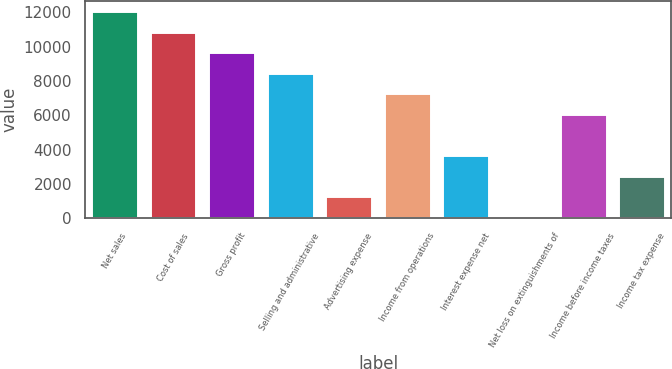<chart> <loc_0><loc_0><loc_500><loc_500><bar_chart><fcel>Net sales<fcel>Cost of sales<fcel>Gross profit<fcel>Selling and administrative<fcel>Advertising expense<fcel>Income from operations<fcel>Interest expense net<fcel>Net loss on extinguishments of<fcel>Income before income taxes<fcel>Income tax expense<nl><fcel>12074.5<fcel>10876.1<fcel>9677.74<fcel>8479.36<fcel>1289.08<fcel>7280.98<fcel>3685.84<fcel>90.7<fcel>6082.6<fcel>2487.46<nl></chart> 